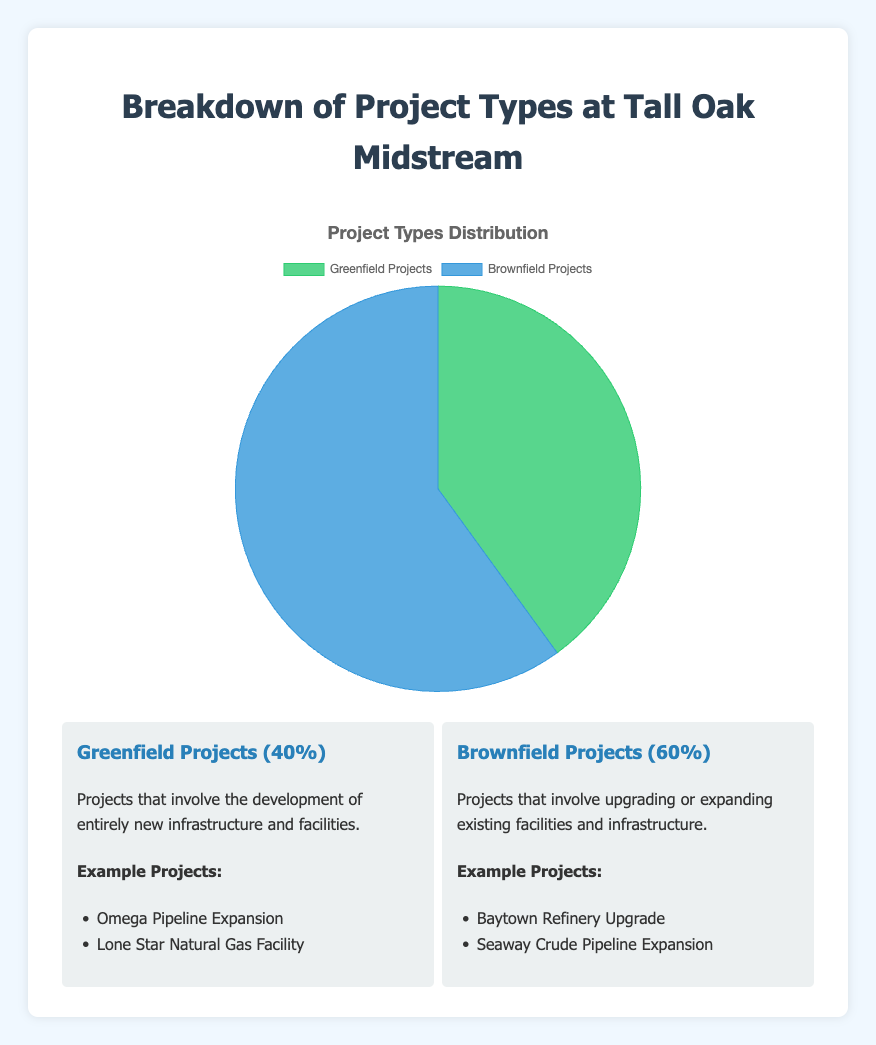What's the percentage of Greenfield Projects? The figure shows that Greenfield Projects constitute 40% of the total projects. This information is directly labeled on the slice of the pie chart for Greenfield Projects.
Answer: 40% What's the percentage of Brownfield Projects? The breakdown in the pie chart indicates that Brownfield Projects account for 60% of the total projects. This percentage is clearly labeled on the pie chart section.
Answer: 60% Which type of project is more common at Tall Oak Midstream, Greenfield or Brownfield Projects? Comparing the percentages given in the pie chart, Brownfield Projects (60%) have a higher percentage than Greenfield Projects (40%).
Answer: Brownfield Projects What's the difference in percentage between Brownfield and Greenfield Projects? Brownfield Projects have a percentage of 60%, and Greenfield Projects have 40%, so the difference is calculated as 60% - 40% = 20%.
Answer: 20% If there are 100 projects at Tall Oak Midstream, how many of them are Greenfield Projects? Given that Greenfield Projects make up 40% of the total projects and there are 100 projects, the number of Greenfield Projects can be calculated as 40% of 100, which is 0.4 * 100 = 40.
Answer: 40 If there are 100 projects at Tall Oak Midstream, how many of them are Brownfield Projects? Since Brownfield Projects account for 60% of the total projects and there are 100 projects, the number of Brownfield Projects is 60% of 100, which equals 0.6 * 100 = 60.
Answer: 60 What is the total percentage of all projects represented in the pie chart? The pie chart represents the entire distribution of projects, so the total percentage is the sum of Greenfield and Brownfield Projects. 40% + 60% = 100%.
Answer: 100% What color represents Greenfield Projects in the pie chart? The Greenfield Projects slice in the pie chart is represented by a green color. This can be observed directly from the visual representation.
Answer: Green What color represents Brownfield Projects in the pie chart? The Brownfield Projects slice in the pie chart is depicted in blue. This color distinction can be identified by looking at the pie chart.
Answer: Blue What are some examples of Greenfield Projects listed? According to the provided information under Greenfield Projects, examples include "Omega Pipeline Expansion" and "Lone Star Natural Gas Facility". This detail is present alongside the pie chart, under the example projects section for Greenfield Projects.
Answer: Omega Pipeline Expansion, Lone Star Natural Gas Facility 